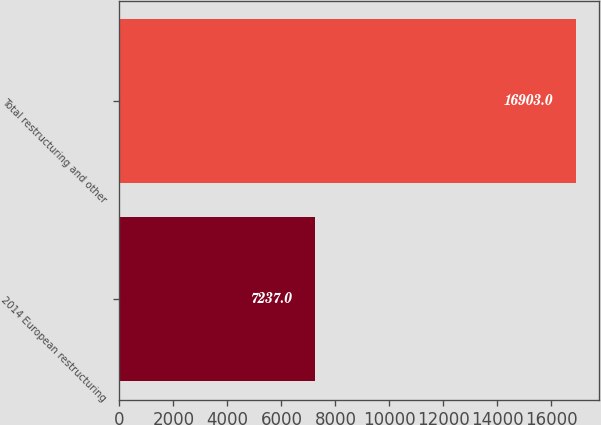Convert chart to OTSL. <chart><loc_0><loc_0><loc_500><loc_500><bar_chart><fcel>2014 European restructuring<fcel>Total restructuring and other<nl><fcel>7237<fcel>16903<nl></chart> 